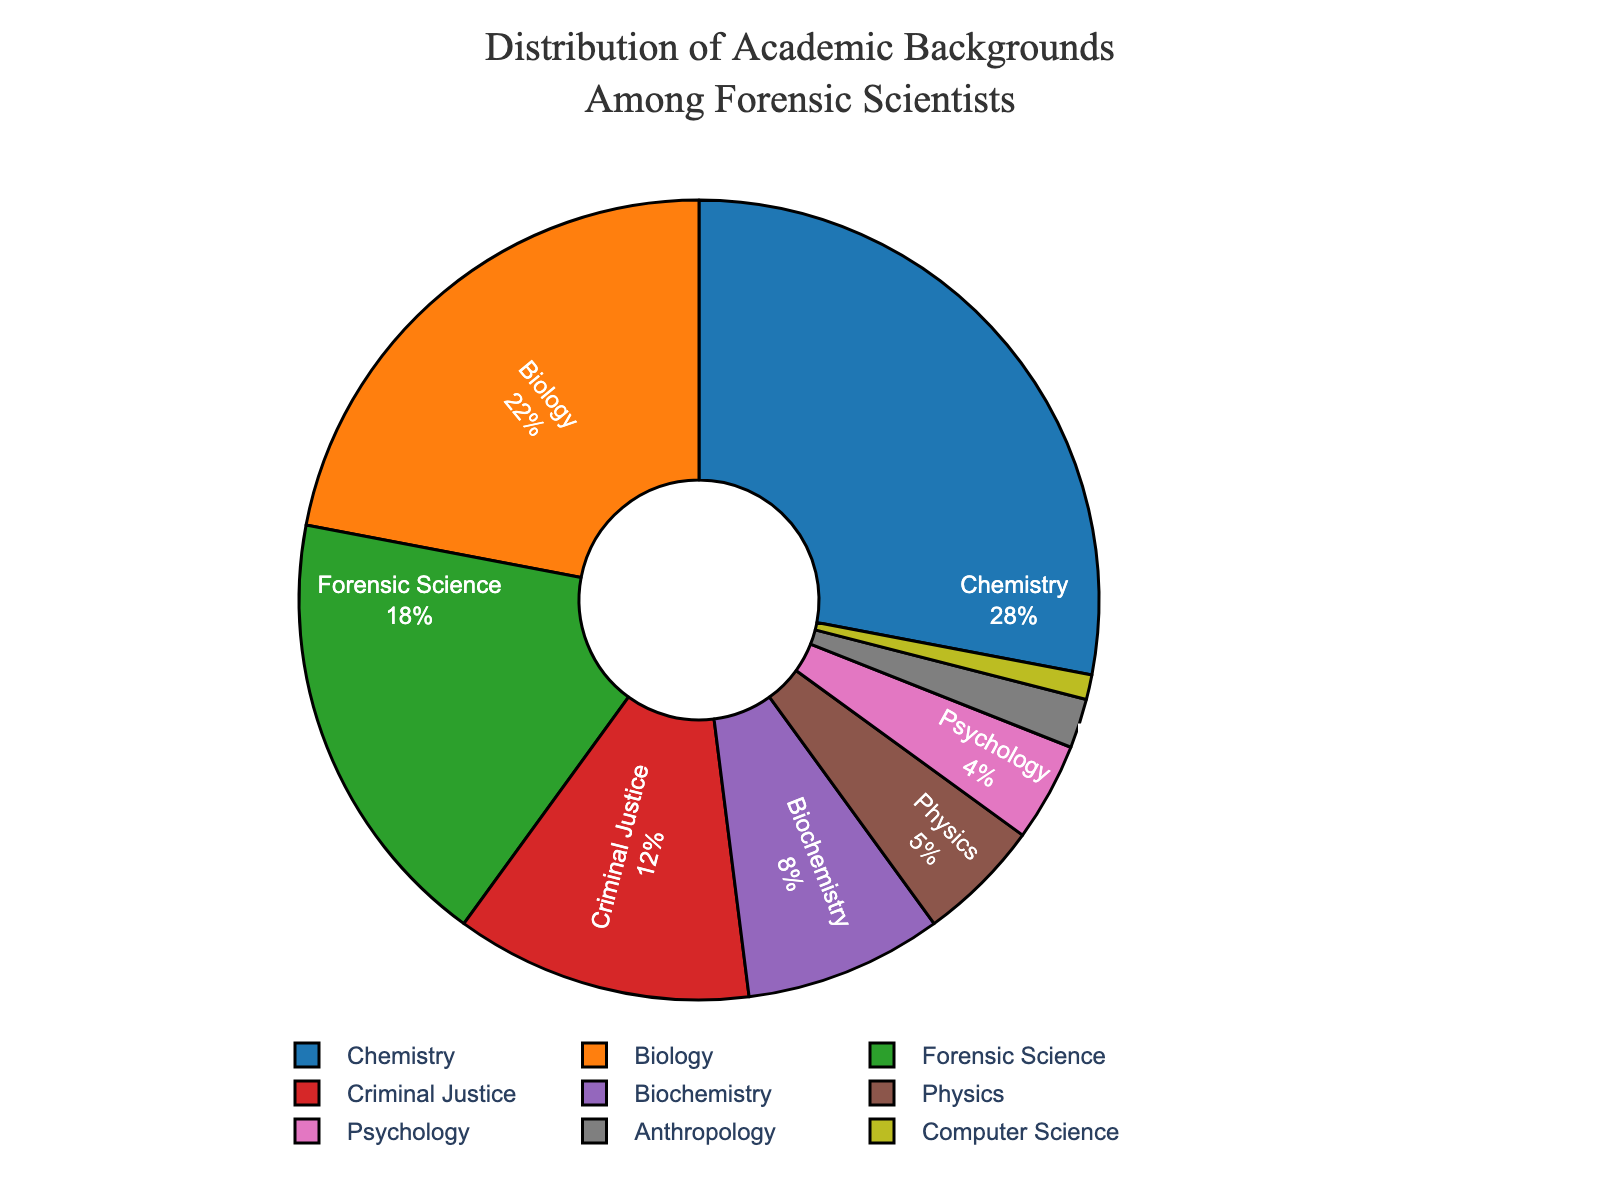What percentage of forensic scientists have a background in Chemistry or Biology combined? To find the combined percentage, add the percentage of forensic scientists with a background in Chemistry (28%) to those with a background in Biology (22%). This gives 28 + 22 = 50.
Answer: 50% Which academic background is the least common among forensic scientists? By examining the pie chart, we can see that Computer Science has the smallest section, which corresponds to 1%.
Answer: Computer Science What is the difference in percentage between forensic scientists with a background in Chemistry and those with a background in Forensic Science? The percentage of forensic scientists with a background in Chemistry is 28%, and for Forensic Science, it is 18%. The difference is 28 - 18 = 10.
Answer: 10% How much larger is the percentage of forensic scientists with a Biology background compared to those with a Criminal Justice background? The percentage for Biology is 22%, and for Criminal Justice, it is 12%. The difference is 22 - 12 = 10.
Answer: 10% What is the total percentage of forensic scientists when combining the backgrounds of Biochemistry, Physics, Psychology, and Anthropology? The percentages are Biochemistry (8%), Physics (5%), Psychology (4%), and Anthropology (2%). Adding these together: 8 + 5 + 4 + 2 = 19.
Answer: 19% Which academic background(s) have a combined percentage greater than or equal to 30% when summed with Criminal Justice? Criminal Justice is 12%. Among other backgrounds, Chemistry (28%) and Biology (22%) alone or coupled with Forensic Science (18%) exceed 30% when summed: 12 + 18 = 30. Therefore, any of the combinations with Biology and Chemistry are more than 30%.
Answer: Chemistry, Biology What percentage of forensic scientists do not have a background in Chemistry, Biology, or Forensic Science? Subtract the cumulative percentage of Chemistry (28%), Biology (22%), and Forensic Science (18%) from 100%. This gives 100 - (28 + 22 + 18) = 100 - 68 = 32.
Answer: 32% How does the percentage of forensic scientists with a background in Physics compare to those in Psychology? The percentage with a Physics background is 5%, and those in Psychology have 4%. Physics is 1% higher than Psychology.
Answer: Physics is 1% higher What is the average percentage of forensic scientists having backgrounds in Criminal Justice, Biochemistry, and Anthropology? Sum the percentages of Criminal Justice (12%), Biochemistry (8%), and Anthropology (2%), then divide by the number of backgrounds. The total is 12 + 8 + 2 = 22. The average is 22 / 3 = 7.33.
Answer: 7.33% Which field is represented by the second smallest segment in the pie chart? After Computer Science (1%), the next smallest segment is Anthropology, which is 2%.
Answer: Anthropology 